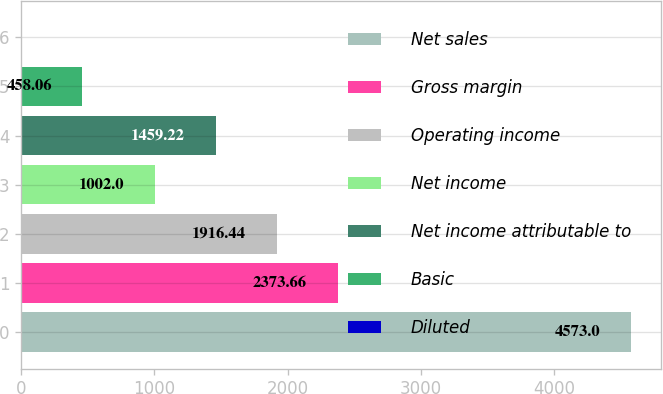Convert chart to OTSL. <chart><loc_0><loc_0><loc_500><loc_500><bar_chart><fcel>Net sales<fcel>Gross margin<fcel>Operating income<fcel>Net income<fcel>Net income attributable to<fcel>Basic<fcel>Diluted<nl><fcel>4573<fcel>2373.66<fcel>1916.44<fcel>1002<fcel>1459.22<fcel>458.06<fcel>0.84<nl></chart> 